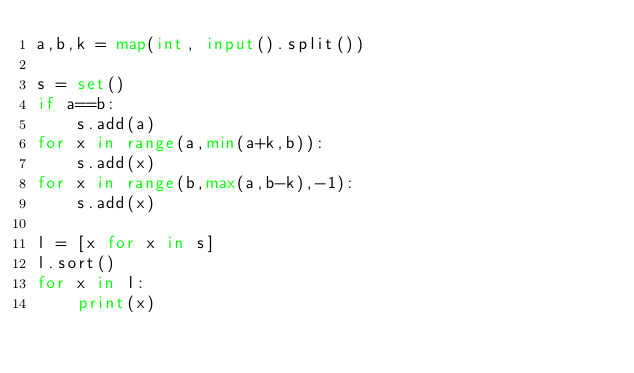Convert code to text. <code><loc_0><loc_0><loc_500><loc_500><_Python_>a,b,k = map(int, input().split())

s = set()
if a==b:
    s.add(a)
for x in range(a,min(a+k,b)):
    s.add(x)
for x in range(b,max(a,b-k),-1):
    s.add(x)

l = [x for x in s]
l.sort()
for x in l:
    print(x)</code> 